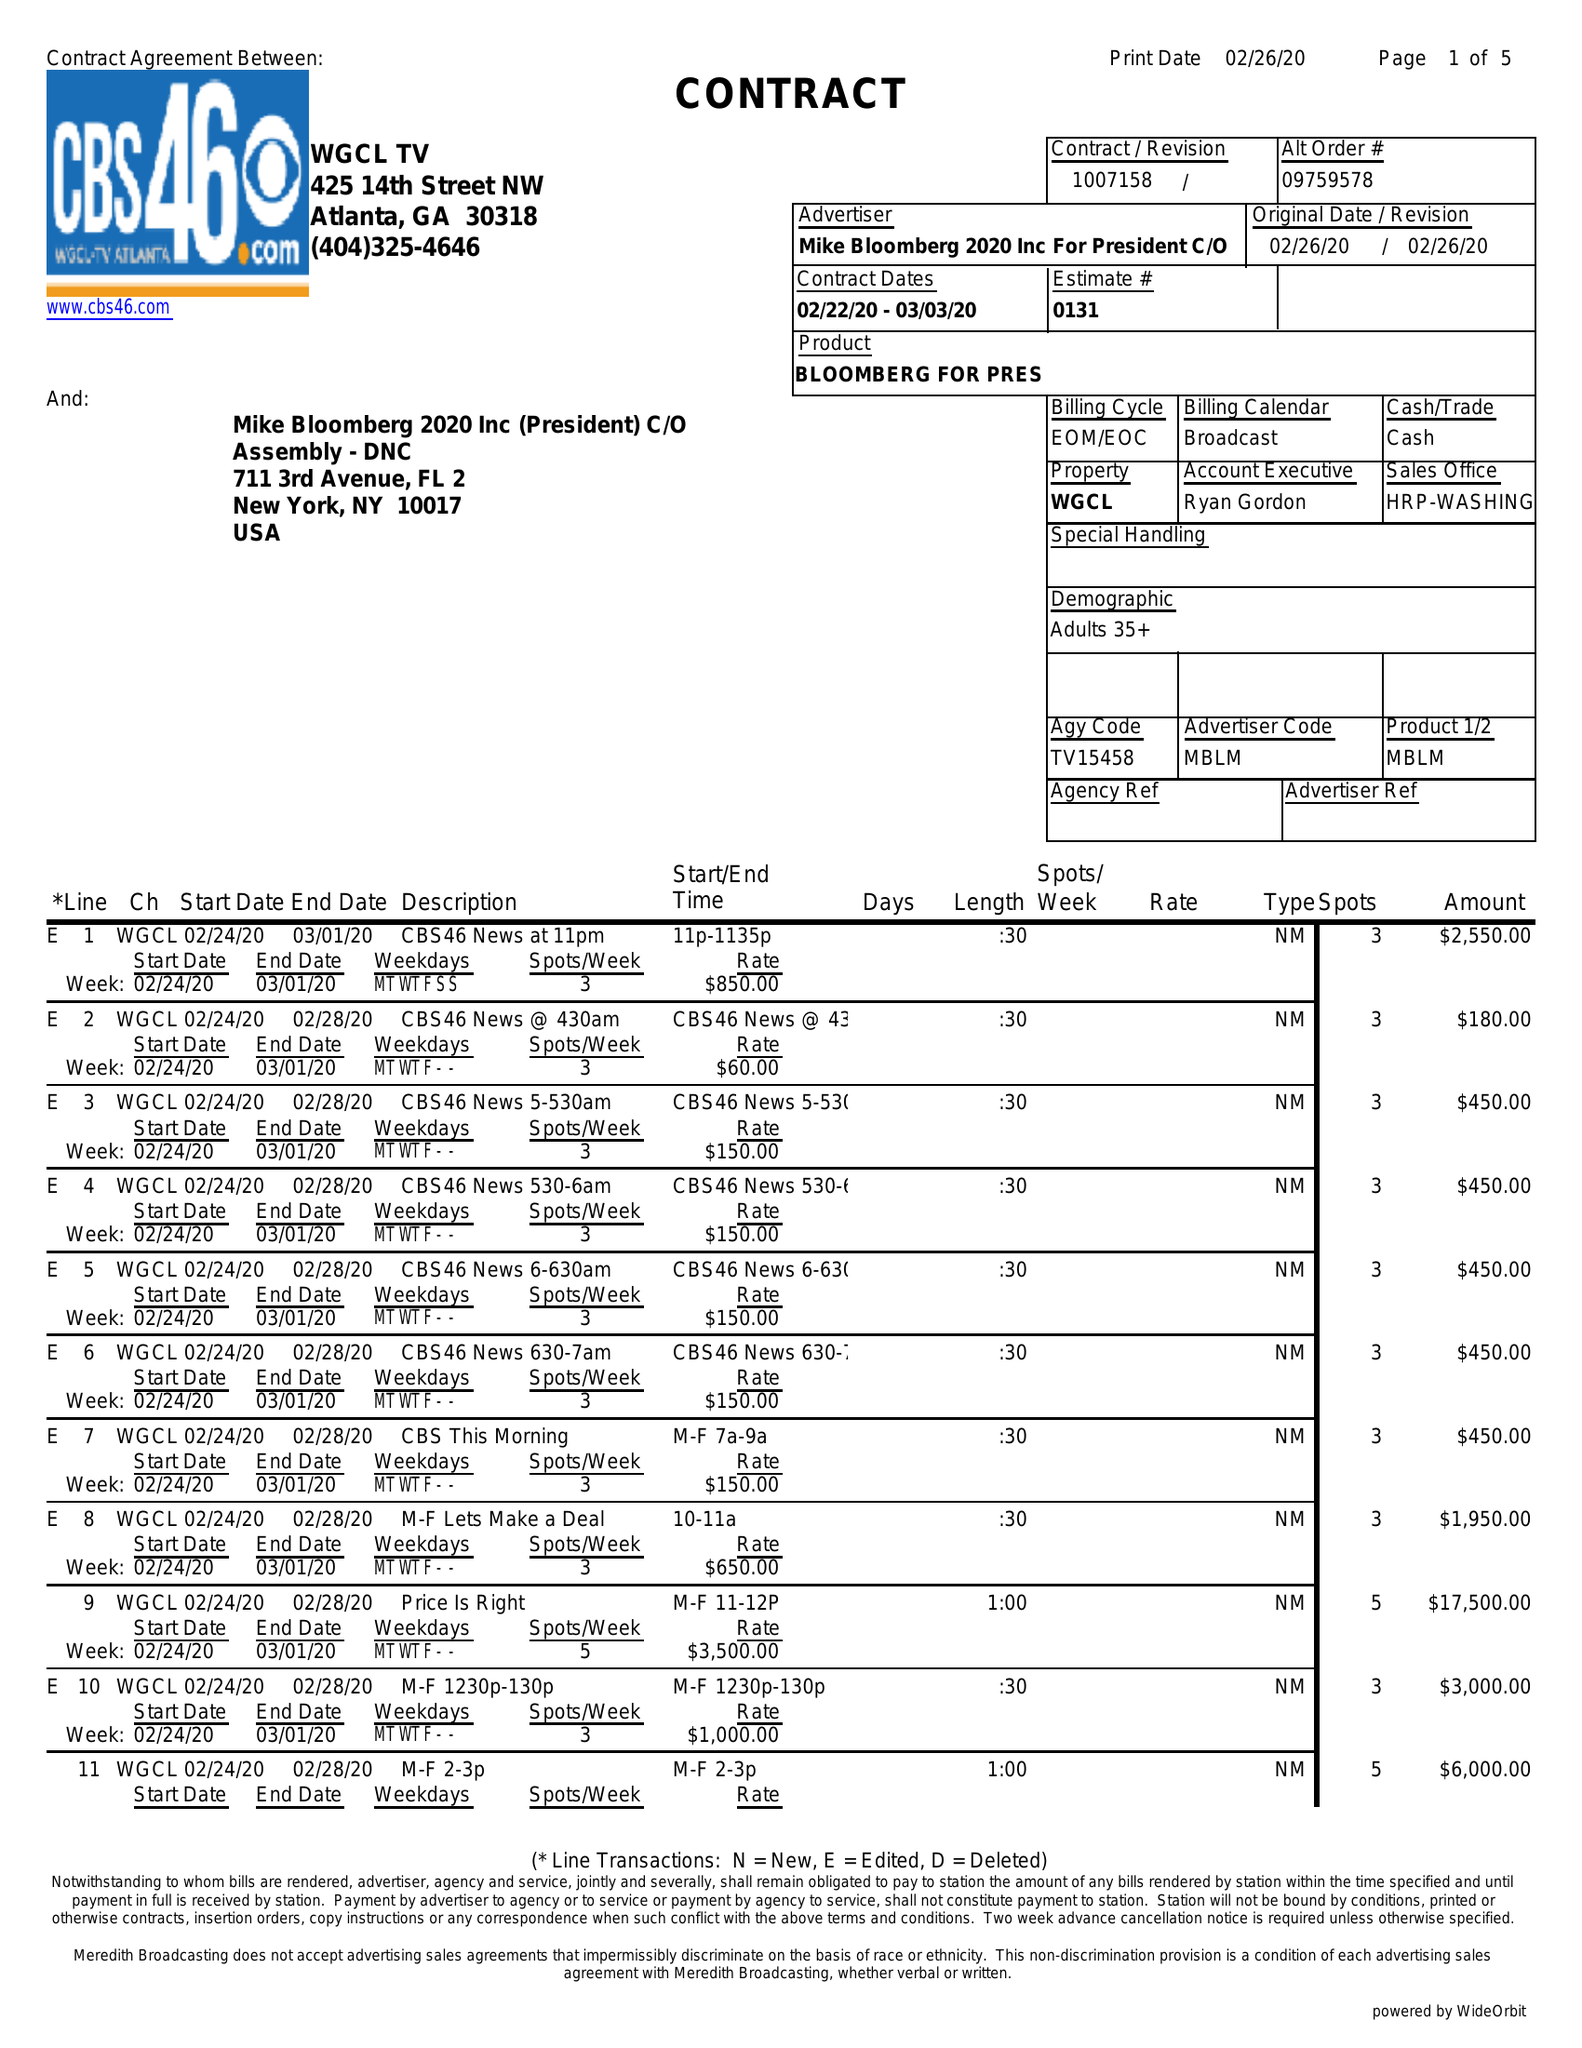What is the value for the gross_amount?
Answer the question using a single word or phrase. 179980.00 